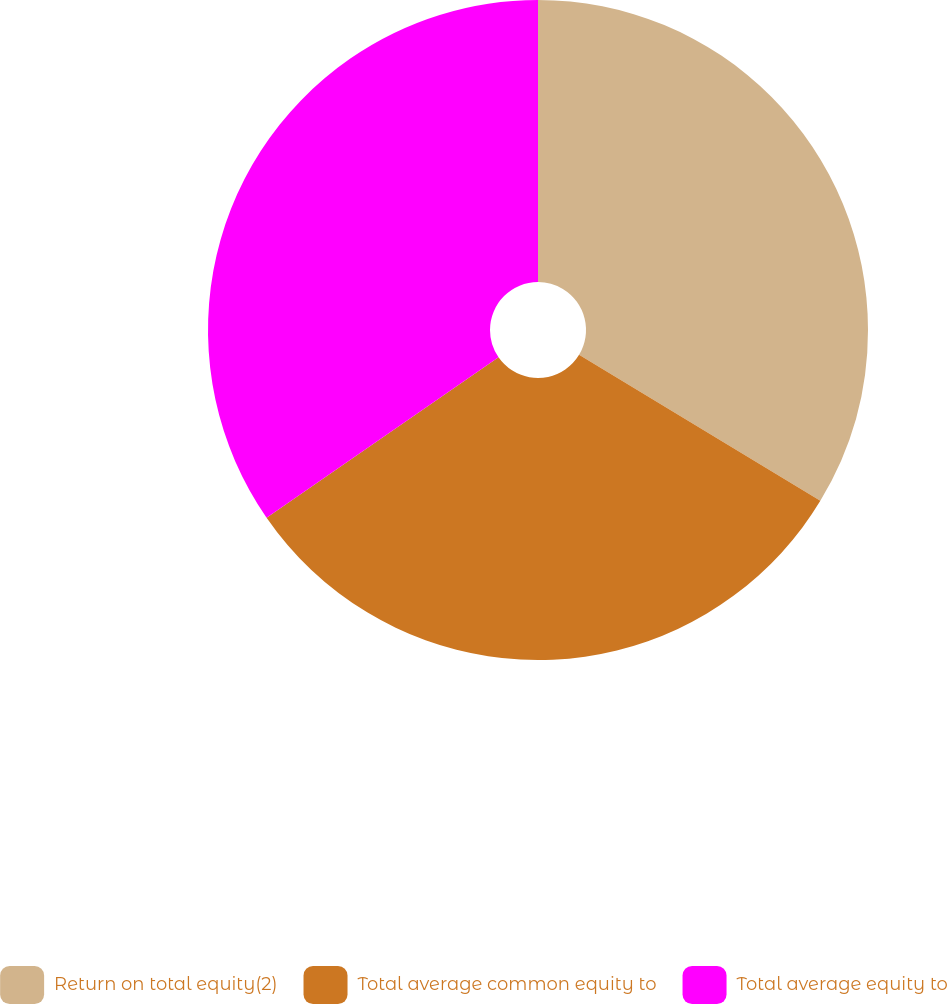Convert chart. <chart><loc_0><loc_0><loc_500><loc_500><pie_chart><fcel>Return on total equity(2)<fcel>Total average common equity to<fcel>Total average equity to<nl><fcel>33.66%<fcel>31.71%<fcel>34.63%<nl></chart> 